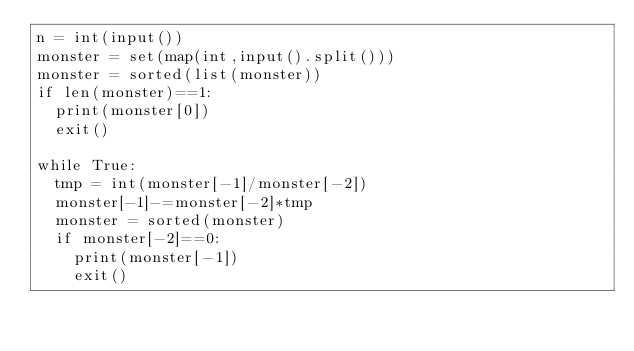<code> <loc_0><loc_0><loc_500><loc_500><_Python_>n = int(input())
monster = set(map(int,input().split()))
monster = sorted(list(monster))
if len(monster)==1:
  print(monster[0])
  exit()

while True:
  tmp = int(monster[-1]/monster[-2])
  monster[-1]-=monster[-2]*tmp
  monster = sorted(monster)
  if monster[-2]==0:
    print(monster[-1])
    exit()</code> 